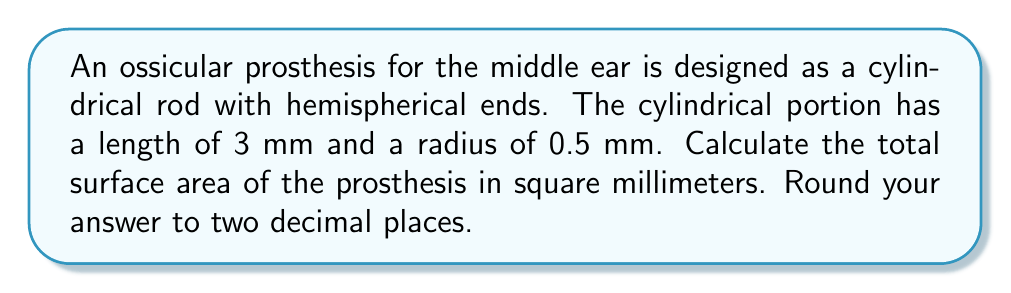What is the answer to this math problem? To solve this problem, we need to calculate the surface area of the cylindrical portion and the two hemispherical ends, then sum them up.

1. Surface area of the cylindrical portion:
   $$A_{cylinder} = 2\pi r h$$
   where $r$ is the radius and $h$ is the height (length) of the cylinder.
   $$A_{cylinder} = 2\pi (0.5 \text{ mm})(3 \text{ mm}) = 3\pi \text{ mm}^2$$

2. Surface area of one hemispherical end:
   $$A_{hemisphere} = 2\pi r^2$$
   $$A_{hemisphere} = 2\pi (0.5 \text{ mm})^2 = \frac{\pi}{2} \text{ mm}^2$$

3. Total surface area of both hemispherical ends:
   $$A_{both_hemispheres} = 2 \cdot \frac{\pi}{2} \text{ mm}^2 = \pi \text{ mm}^2$$

4. Total surface area of the prosthesis:
   $$A_{total} = A_{cylinder} + A_{both_hemispheres}$$
   $$A_{total} = 3\pi \text{ mm}^2 + \pi \text{ mm}^2 = 4\pi \text{ mm}^2$$

5. Convert to a numerical value and round to two decimal places:
   $$A_{total} = 4\pi \text{ mm}^2 \approx 12.57 \text{ mm}^2$$
Answer: $12.57 \text{ mm}^2$ 